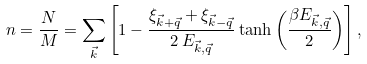<formula> <loc_0><loc_0><loc_500><loc_500>n = \frac { N } { M } = \sum _ { \vec { k } } \left [ 1 - \frac { \xi _ { \vec { k } + \vec { q } } + \xi _ { \vec { k } - \vec { q } } } { 2 \, E _ { \vec { k } , \vec { q } } } \tanh \left ( \frac { \beta E _ { \vec { k } , \vec { q } } } { 2 } \right ) \right ] ,</formula> 